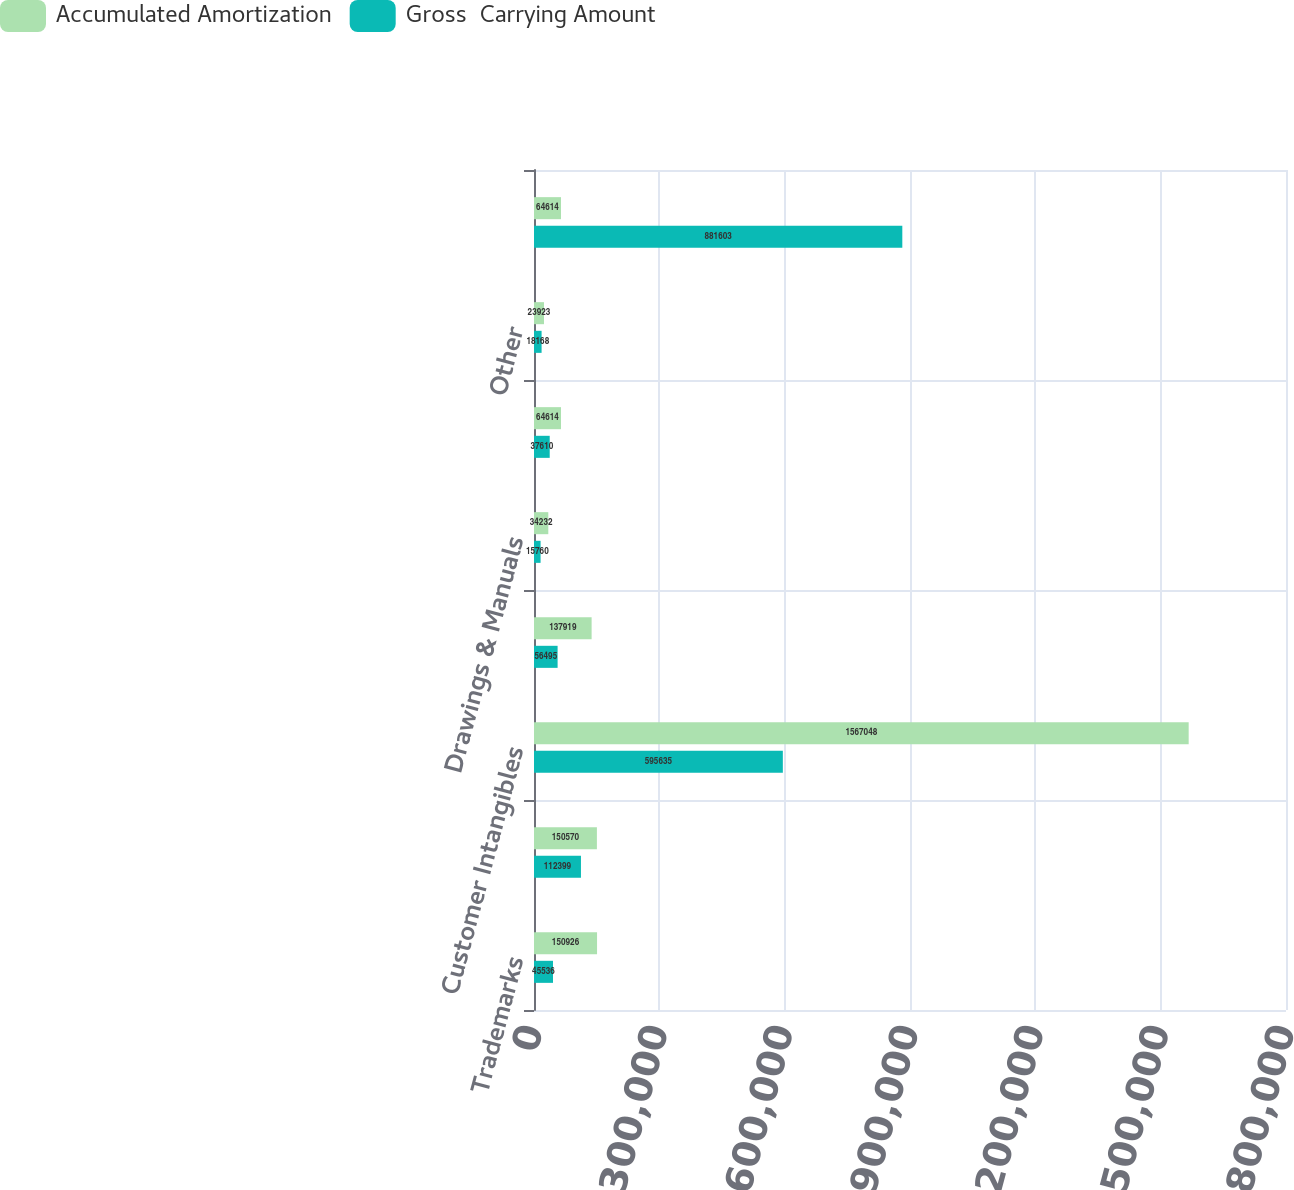Convert chart to OTSL. <chart><loc_0><loc_0><loc_500><loc_500><stacked_bar_chart><ecel><fcel>Trademarks<fcel>Patents<fcel>Customer Intangibles<fcel>Unpatented Technologies<fcel>Drawings & Manuals<fcel>Distributor Relationships<fcel>Other<fcel>Total<nl><fcel>Accumulated Amortization<fcel>150926<fcel>150570<fcel>1.56705e+06<fcel>137919<fcel>34232<fcel>64614<fcel>23923<fcel>64614<nl><fcel>Gross  Carrying Amount<fcel>45536<fcel>112399<fcel>595635<fcel>56495<fcel>15760<fcel>37610<fcel>18168<fcel>881603<nl></chart> 